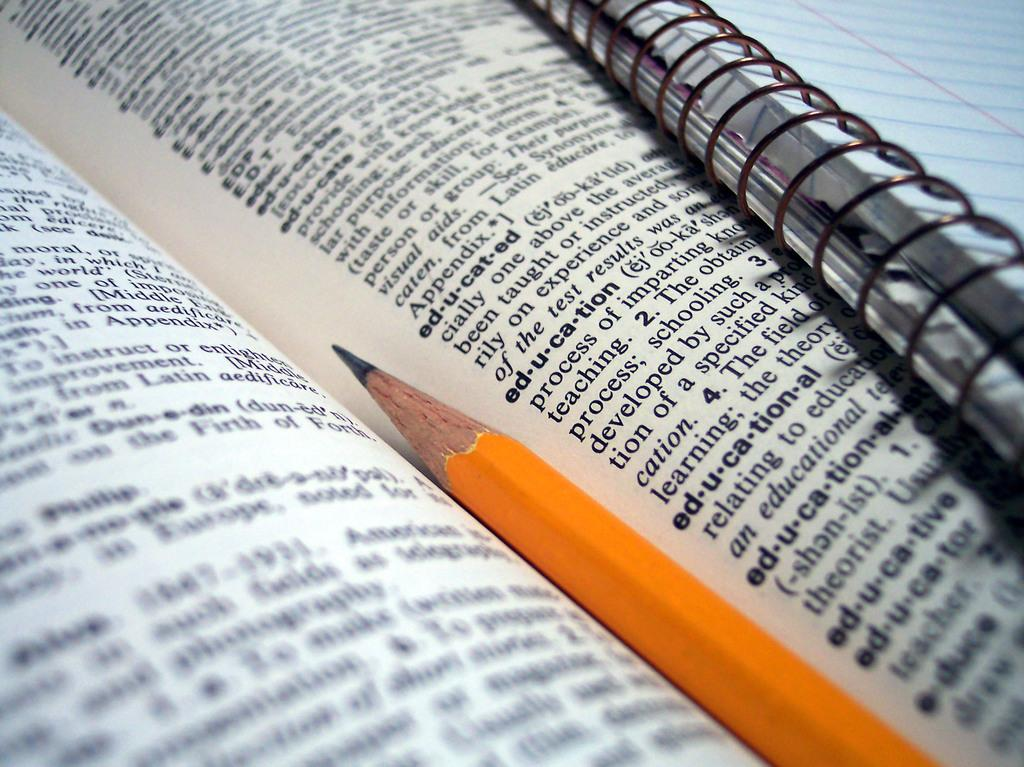<image>
Create a compact narrative representing the image presented. A pencil sits in the middle of a dictionary next to the word educated 